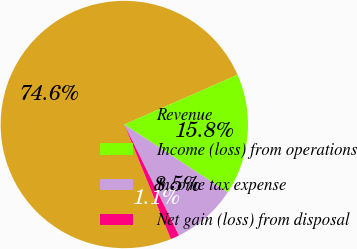Convert chart. <chart><loc_0><loc_0><loc_500><loc_500><pie_chart><fcel>Revenue<fcel>Income (loss) from operations<fcel>Income tax expense<fcel>Net gain (loss) from disposal<nl><fcel>74.55%<fcel>15.82%<fcel>8.48%<fcel>1.14%<nl></chart> 